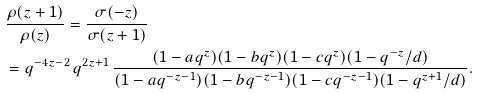Convert formula to latex. <formula><loc_0><loc_0><loc_500><loc_500>& \frac { \rho ( z + 1 ) } { \rho ( z ) } = \frac { \sigma ( - z ) } { \sigma ( z + 1 ) } \\ & = q ^ { - 4 z - 2 } \, q ^ { 2 z + 1 } \, \frac { ( 1 - a q ^ { z } ) ( 1 - b q ^ { z } ) ( 1 - c q ^ { z } ) ( 1 - q ^ { - z } / d ) } { ( 1 - a q ^ { - z - 1 } ) ( 1 - b q ^ { - z - 1 } ) ( 1 - c q ^ { - z - 1 } ) ( 1 - q ^ { z + 1 } / d ) } .</formula> 